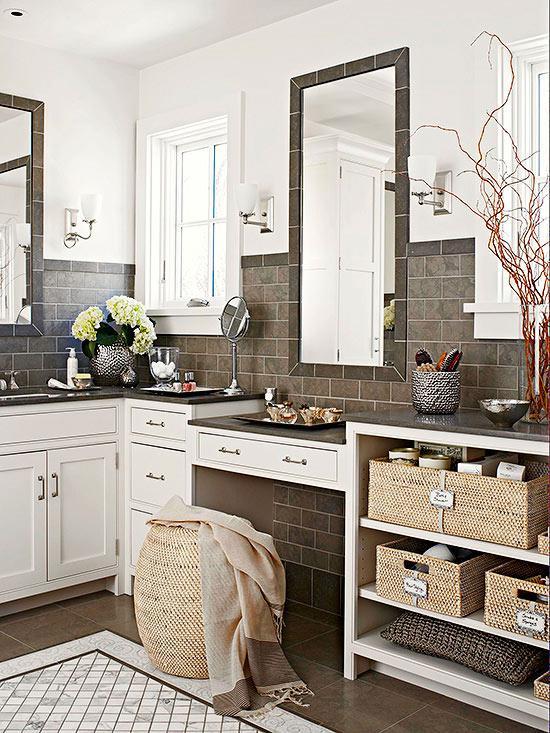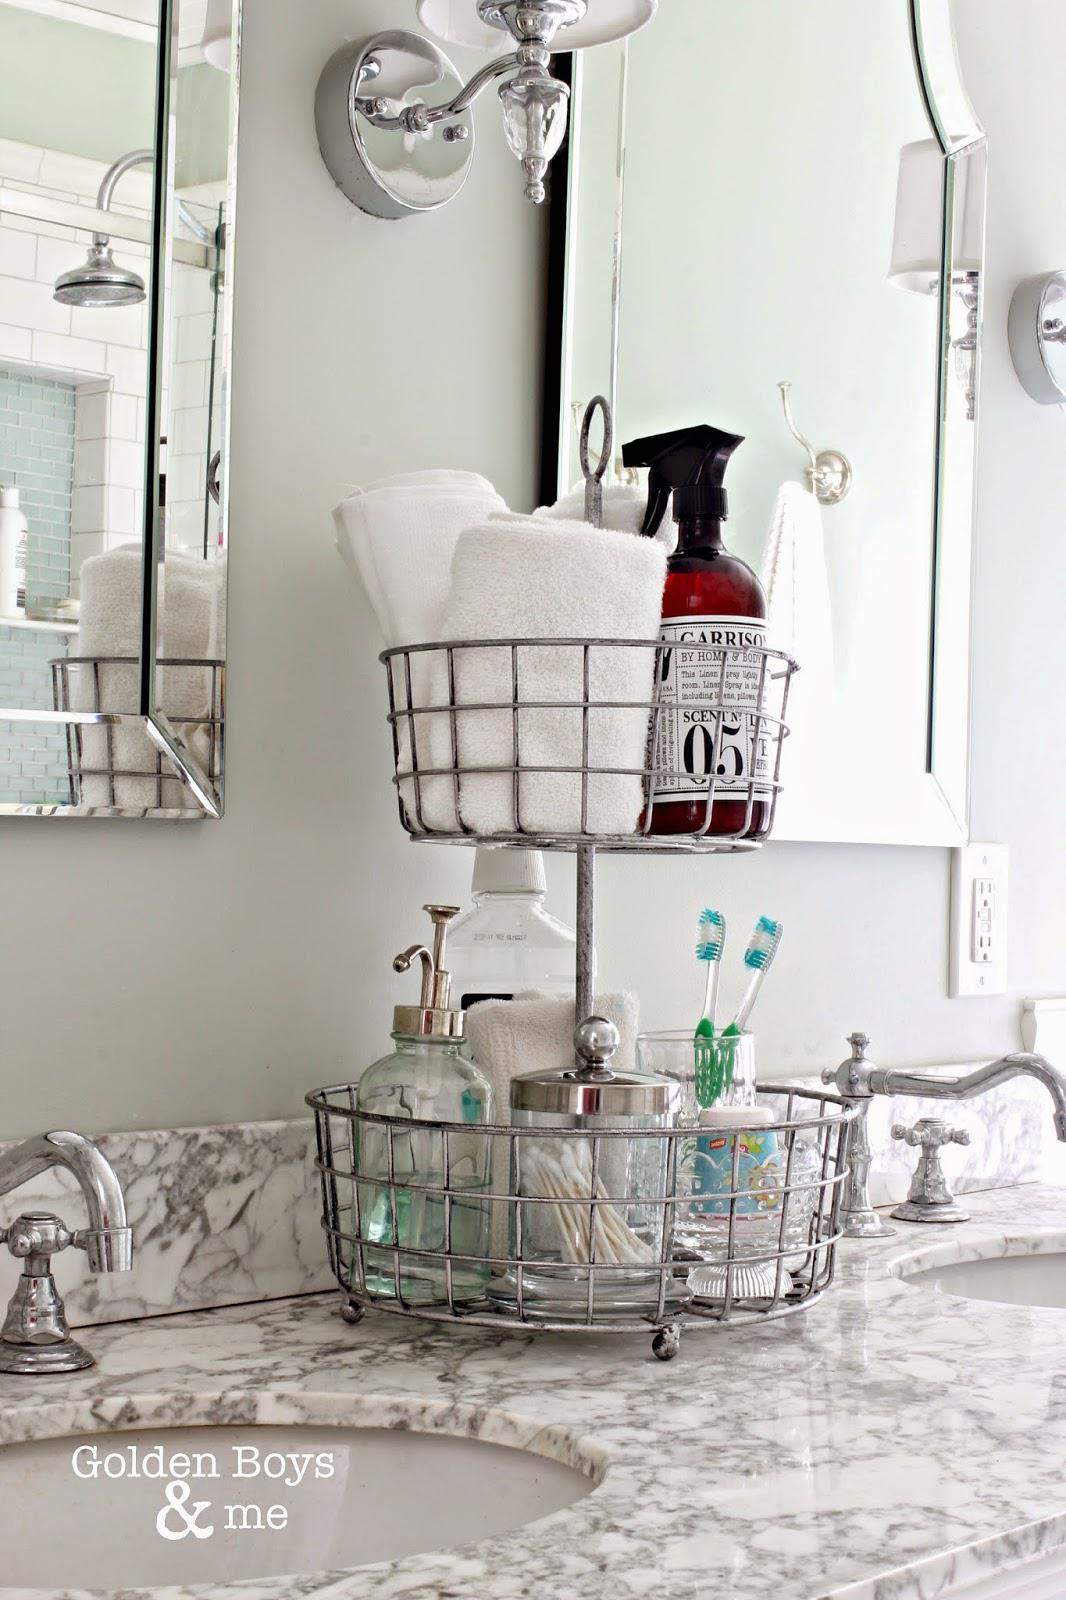The first image is the image on the left, the second image is the image on the right. For the images displayed, is the sentence "There is a sink in one of the images." factually correct? Answer yes or no. Yes. 